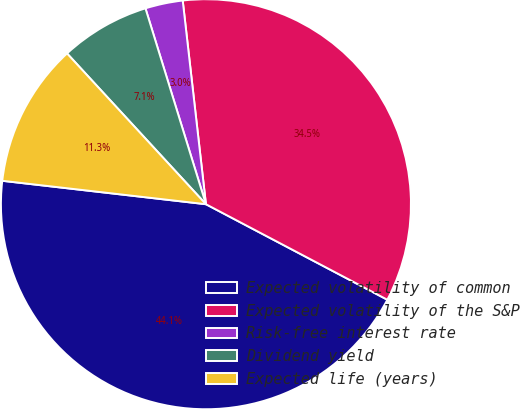Convert chart. <chart><loc_0><loc_0><loc_500><loc_500><pie_chart><fcel>Expected volatility of common<fcel>Expected volatility of the S&P<fcel>Risk-free interest rate<fcel>Dividend yield<fcel>Expected life (years)<nl><fcel>44.11%<fcel>34.52%<fcel>2.96%<fcel>7.08%<fcel>11.33%<nl></chart> 